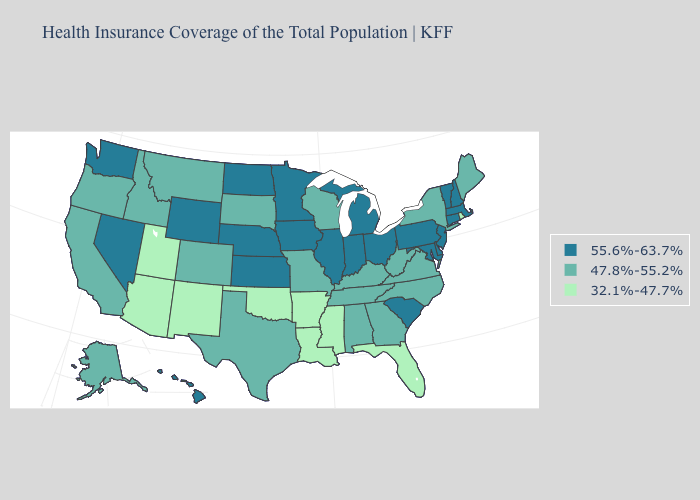How many symbols are there in the legend?
Write a very short answer. 3. Name the states that have a value in the range 32.1%-47.7%?
Be succinct. Arizona, Arkansas, Florida, Louisiana, Mississippi, New Mexico, Oklahoma, Rhode Island, Utah. Among the states that border Iowa , which have the lowest value?
Keep it brief. Missouri, South Dakota, Wisconsin. Does Texas have the highest value in the USA?
Write a very short answer. No. Name the states that have a value in the range 47.8%-55.2%?
Keep it brief. Alabama, Alaska, California, Colorado, Georgia, Idaho, Kentucky, Maine, Missouri, Montana, New York, North Carolina, Oregon, South Dakota, Tennessee, Texas, Virginia, West Virginia, Wisconsin. Name the states that have a value in the range 55.6%-63.7%?
Answer briefly. Connecticut, Delaware, Hawaii, Illinois, Indiana, Iowa, Kansas, Maryland, Massachusetts, Michigan, Minnesota, Nebraska, Nevada, New Hampshire, New Jersey, North Dakota, Ohio, Pennsylvania, South Carolina, Vermont, Washington, Wyoming. What is the value of Florida?
Keep it brief. 32.1%-47.7%. Among the states that border Indiana , which have the lowest value?
Answer briefly. Kentucky. What is the value of Michigan?
Write a very short answer. 55.6%-63.7%. What is the highest value in the Northeast ?
Write a very short answer. 55.6%-63.7%. Does Pennsylvania have the same value as Connecticut?
Quick response, please. Yes. What is the lowest value in the USA?
Be succinct. 32.1%-47.7%. Name the states that have a value in the range 55.6%-63.7%?
Concise answer only. Connecticut, Delaware, Hawaii, Illinois, Indiana, Iowa, Kansas, Maryland, Massachusetts, Michigan, Minnesota, Nebraska, Nevada, New Hampshire, New Jersey, North Dakota, Ohio, Pennsylvania, South Carolina, Vermont, Washington, Wyoming. What is the value of North Dakota?
Short answer required. 55.6%-63.7%. Name the states that have a value in the range 32.1%-47.7%?
Write a very short answer. Arizona, Arkansas, Florida, Louisiana, Mississippi, New Mexico, Oklahoma, Rhode Island, Utah. 